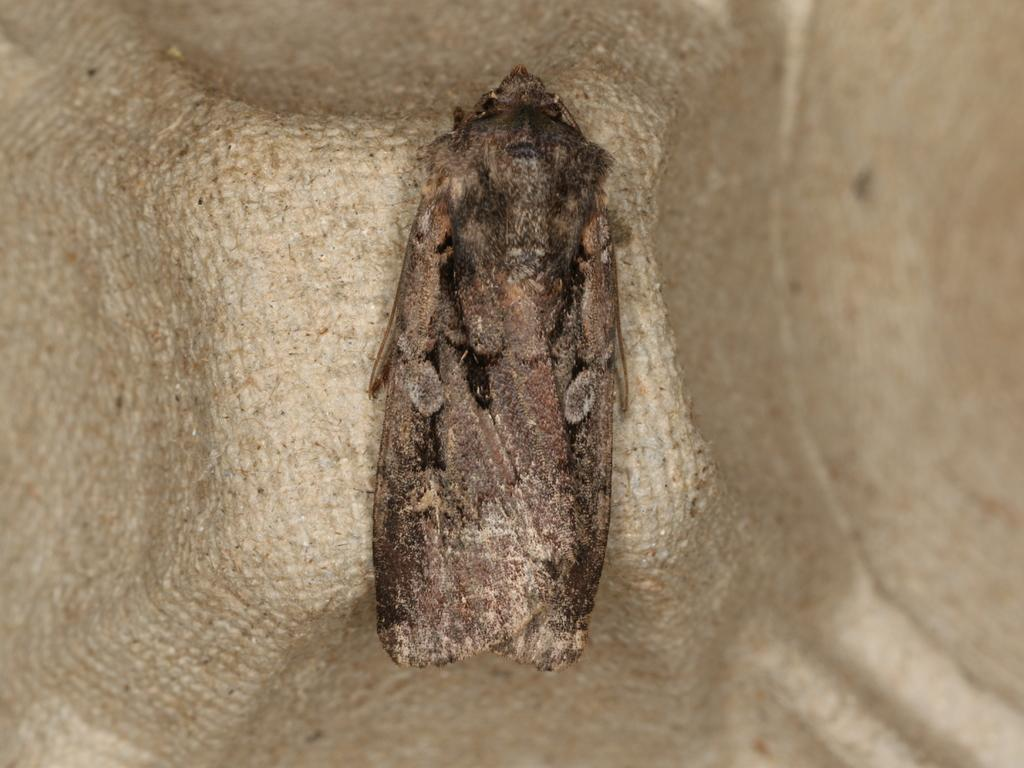What type of creature can be seen in the image? There is an insect in the image. What type of flower is blooming in the fog in the image? There is no flower or fog present in the image; it only features an insect. 